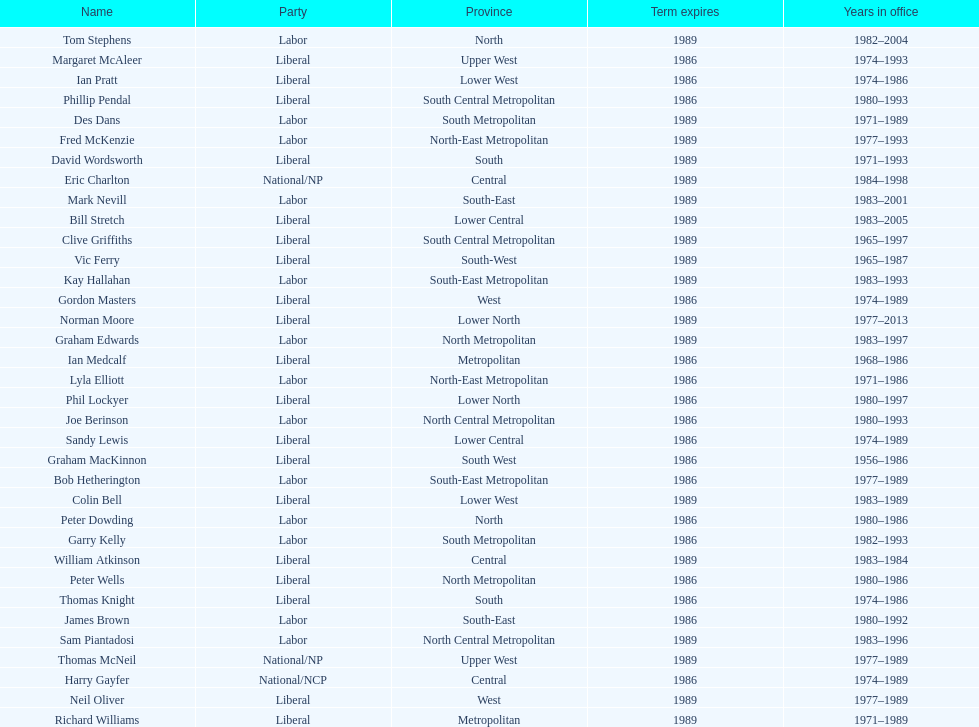Who has had the shortest term in office William Atkinson. 